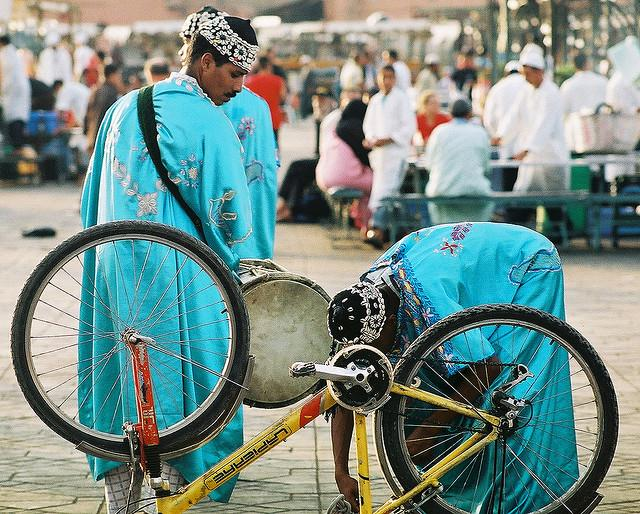What mode of transportation is upside-down?

Choices:
A) bicycle
B) skateboard
C) scooter
D) moped bicycle 